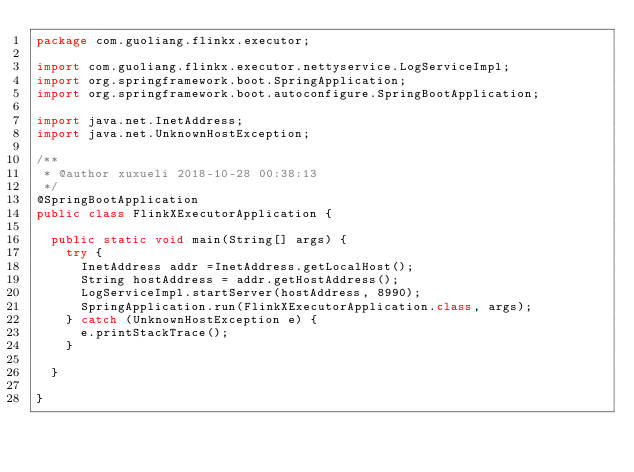<code> <loc_0><loc_0><loc_500><loc_500><_Java_>package com.guoliang.flinkx.executor;

import com.guoliang.flinkx.executor.nettyservice.LogServiceImpl;
import org.springframework.boot.SpringApplication;
import org.springframework.boot.autoconfigure.SpringBootApplication;

import java.net.InetAddress;
import java.net.UnknownHostException;

/**
 * @author xuxueli 2018-10-28 00:38:13
 */
@SpringBootApplication
public class FlinkXExecutorApplication {

	public static void main(String[] args) {
		try {
			InetAddress addr =InetAddress.getLocalHost();
			String hostAddress = addr.getHostAddress();
			LogServiceImpl.startServer(hostAddress, 8990);
			SpringApplication.run(FlinkXExecutorApplication.class, args);
		} catch (UnknownHostException e) {
			e.printStackTrace();
		}

	}

}
</code> 